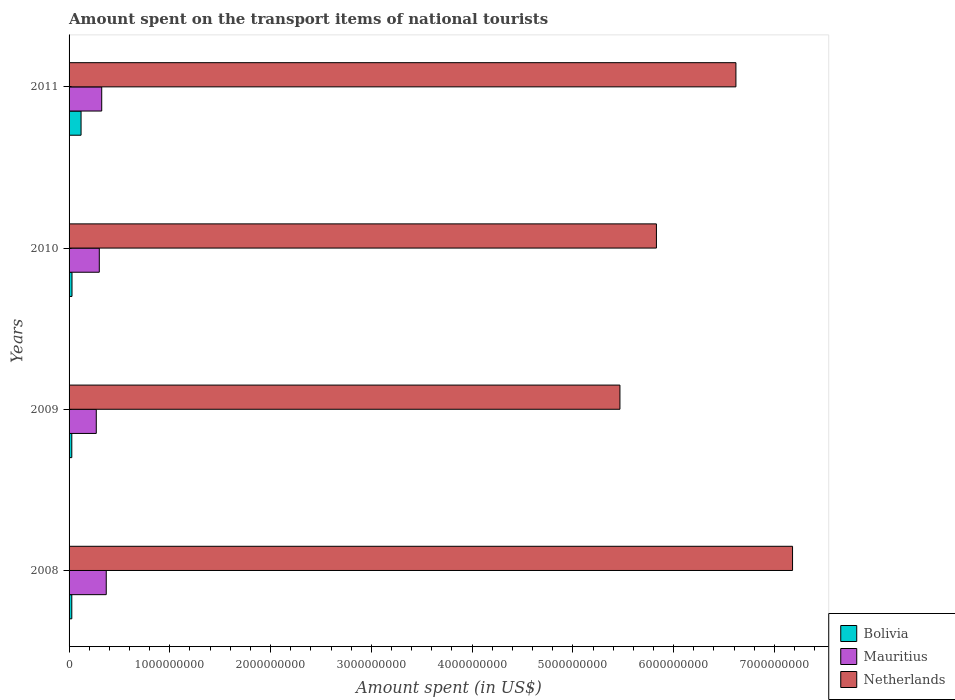How many different coloured bars are there?
Give a very brief answer. 3. Are the number of bars per tick equal to the number of legend labels?
Your answer should be very brief. Yes. How many bars are there on the 2nd tick from the top?
Keep it short and to the point. 3. In how many cases, is the number of bars for a given year not equal to the number of legend labels?
Offer a terse response. 0. What is the amount spent on the transport items of national tourists in Bolivia in 2011?
Keep it short and to the point. 1.19e+08. Across all years, what is the maximum amount spent on the transport items of national tourists in Bolivia?
Offer a terse response. 1.19e+08. Across all years, what is the minimum amount spent on the transport items of national tourists in Bolivia?
Your answer should be compact. 2.70e+07. In which year was the amount spent on the transport items of national tourists in Bolivia minimum?
Your answer should be very brief. 2008. What is the total amount spent on the transport items of national tourists in Bolivia in the graph?
Your answer should be compact. 2.02e+08. What is the difference between the amount spent on the transport items of national tourists in Bolivia in 2010 and that in 2011?
Your answer should be very brief. -9.00e+07. What is the difference between the amount spent on the transport items of national tourists in Netherlands in 2010 and the amount spent on the transport items of national tourists in Bolivia in 2011?
Offer a very short reply. 5.71e+09. What is the average amount spent on the transport items of national tourists in Mauritius per year?
Provide a succinct answer. 3.16e+08. In the year 2008, what is the difference between the amount spent on the transport items of national tourists in Netherlands and amount spent on the transport items of national tourists in Bolivia?
Make the answer very short. 7.15e+09. What is the ratio of the amount spent on the transport items of national tourists in Netherlands in 2009 to that in 2010?
Make the answer very short. 0.94. What is the difference between the highest and the second highest amount spent on the transport items of national tourists in Netherlands?
Offer a very short reply. 5.62e+08. What is the difference between the highest and the lowest amount spent on the transport items of national tourists in Netherlands?
Offer a terse response. 1.71e+09. In how many years, is the amount spent on the transport items of national tourists in Netherlands greater than the average amount spent on the transport items of national tourists in Netherlands taken over all years?
Provide a short and direct response. 2. Is the sum of the amount spent on the transport items of national tourists in Mauritius in 2008 and 2009 greater than the maximum amount spent on the transport items of national tourists in Netherlands across all years?
Offer a terse response. No. How many bars are there?
Provide a short and direct response. 12. Are all the bars in the graph horizontal?
Ensure brevity in your answer.  Yes. How many years are there in the graph?
Your response must be concise. 4. Are the values on the major ticks of X-axis written in scientific E-notation?
Your answer should be very brief. No. How many legend labels are there?
Your answer should be compact. 3. What is the title of the graph?
Offer a terse response. Amount spent on the transport items of national tourists. What is the label or title of the X-axis?
Provide a succinct answer. Amount spent (in US$). What is the Amount spent (in US$) of Bolivia in 2008?
Make the answer very short. 2.70e+07. What is the Amount spent (in US$) in Mauritius in 2008?
Your answer should be very brief. 3.69e+08. What is the Amount spent (in US$) in Netherlands in 2008?
Your answer should be compact. 7.18e+09. What is the Amount spent (in US$) in Bolivia in 2009?
Keep it short and to the point. 2.70e+07. What is the Amount spent (in US$) in Mauritius in 2009?
Your answer should be very brief. 2.70e+08. What is the Amount spent (in US$) of Netherlands in 2009?
Give a very brief answer. 5.47e+09. What is the Amount spent (in US$) of Bolivia in 2010?
Offer a terse response. 2.90e+07. What is the Amount spent (in US$) of Mauritius in 2010?
Your response must be concise. 3.00e+08. What is the Amount spent (in US$) in Netherlands in 2010?
Give a very brief answer. 5.83e+09. What is the Amount spent (in US$) of Bolivia in 2011?
Keep it short and to the point. 1.19e+08. What is the Amount spent (in US$) in Mauritius in 2011?
Your answer should be compact. 3.24e+08. What is the Amount spent (in US$) in Netherlands in 2011?
Provide a short and direct response. 6.62e+09. Across all years, what is the maximum Amount spent (in US$) in Bolivia?
Offer a terse response. 1.19e+08. Across all years, what is the maximum Amount spent (in US$) of Mauritius?
Provide a succinct answer. 3.69e+08. Across all years, what is the maximum Amount spent (in US$) in Netherlands?
Your answer should be compact. 7.18e+09. Across all years, what is the minimum Amount spent (in US$) in Bolivia?
Offer a very short reply. 2.70e+07. Across all years, what is the minimum Amount spent (in US$) of Mauritius?
Your response must be concise. 2.70e+08. Across all years, what is the minimum Amount spent (in US$) of Netherlands?
Your answer should be compact. 5.47e+09. What is the total Amount spent (in US$) in Bolivia in the graph?
Provide a succinct answer. 2.02e+08. What is the total Amount spent (in US$) in Mauritius in the graph?
Provide a short and direct response. 1.26e+09. What is the total Amount spent (in US$) in Netherlands in the graph?
Provide a succinct answer. 2.51e+1. What is the difference between the Amount spent (in US$) of Bolivia in 2008 and that in 2009?
Your answer should be very brief. 0. What is the difference between the Amount spent (in US$) in Mauritius in 2008 and that in 2009?
Your response must be concise. 9.90e+07. What is the difference between the Amount spent (in US$) of Netherlands in 2008 and that in 2009?
Keep it short and to the point. 1.71e+09. What is the difference between the Amount spent (in US$) in Mauritius in 2008 and that in 2010?
Offer a terse response. 6.90e+07. What is the difference between the Amount spent (in US$) of Netherlands in 2008 and that in 2010?
Offer a very short reply. 1.35e+09. What is the difference between the Amount spent (in US$) in Bolivia in 2008 and that in 2011?
Your answer should be very brief. -9.20e+07. What is the difference between the Amount spent (in US$) in Mauritius in 2008 and that in 2011?
Give a very brief answer. 4.50e+07. What is the difference between the Amount spent (in US$) of Netherlands in 2008 and that in 2011?
Provide a short and direct response. 5.62e+08. What is the difference between the Amount spent (in US$) in Mauritius in 2009 and that in 2010?
Make the answer very short. -3.00e+07. What is the difference between the Amount spent (in US$) in Netherlands in 2009 and that in 2010?
Provide a succinct answer. -3.62e+08. What is the difference between the Amount spent (in US$) in Bolivia in 2009 and that in 2011?
Your answer should be very brief. -9.20e+07. What is the difference between the Amount spent (in US$) in Mauritius in 2009 and that in 2011?
Ensure brevity in your answer.  -5.40e+07. What is the difference between the Amount spent (in US$) of Netherlands in 2009 and that in 2011?
Give a very brief answer. -1.15e+09. What is the difference between the Amount spent (in US$) in Bolivia in 2010 and that in 2011?
Make the answer very short. -9.00e+07. What is the difference between the Amount spent (in US$) of Mauritius in 2010 and that in 2011?
Provide a short and direct response. -2.40e+07. What is the difference between the Amount spent (in US$) of Netherlands in 2010 and that in 2011?
Offer a very short reply. -7.89e+08. What is the difference between the Amount spent (in US$) in Bolivia in 2008 and the Amount spent (in US$) in Mauritius in 2009?
Give a very brief answer. -2.43e+08. What is the difference between the Amount spent (in US$) of Bolivia in 2008 and the Amount spent (in US$) of Netherlands in 2009?
Offer a very short reply. -5.44e+09. What is the difference between the Amount spent (in US$) in Mauritius in 2008 and the Amount spent (in US$) in Netherlands in 2009?
Ensure brevity in your answer.  -5.10e+09. What is the difference between the Amount spent (in US$) of Bolivia in 2008 and the Amount spent (in US$) of Mauritius in 2010?
Provide a succinct answer. -2.73e+08. What is the difference between the Amount spent (in US$) of Bolivia in 2008 and the Amount spent (in US$) of Netherlands in 2010?
Make the answer very short. -5.80e+09. What is the difference between the Amount spent (in US$) in Mauritius in 2008 and the Amount spent (in US$) in Netherlands in 2010?
Ensure brevity in your answer.  -5.46e+09. What is the difference between the Amount spent (in US$) in Bolivia in 2008 and the Amount spent (in US$) in Mauritius in 2011?
Make the answer very short. -2.97e+08. What is the difference between the Amount spent (in US$) in Bolivia in 2008 and the Amount spent (in US$) in Netherlands in 2011?
Offer a very short reply. -6.59e+09. What is the difference between the Amount spent (in US$) in Mauritius in 2008 and the Amount spent (in US$) in Netherlands in 2011?
Your answer should be compact. -6.25e+09. What is the difference between the Amount spent (in US$) in Bolivia in 2009 and the Amount spent (in US$) in Mauritius in 2010?
Your answer should be compact. -2.73e+08. What is the difference between the Amount spent (in US$) in Bolivia in 2009 and the Amount spent (in US$) in Netherlands in 2010?
Provide a succinct answer. -5.80e+09. What is the difference between the Amount spent (in US$) of Mauritius in 2009 and the Amount spent (in US$) of Netherlands in 2010?
Give a very brief answer. -5.56e+09. What is the difference between the Amount spent (in US$) in Bolivia in 2009 and the Amount spent (in US$) in Mauritius in 2011?
Provide a succinct answer. -2.97e+08. What is the difference between the Amount spent (in US$) in Bolivia in 2009 and the Amount spent (in US$) in Netherlands in 2011?
Your answer should be compact. -6.59e+09. What is the difference between the Amount spent (in US$) in Mauritius in 2009 and the Amount spent (in US$) in Netherlands in 2011?
Give a very brief answer. -6.35e+09. What is the difference between the Amount spent (in US$) in Bolivia in 2010 and the Amount spent (in US$) in Mauritius in 2011?
Your answer should be very brief. -2.95e+08. What is the difference between the Amount spent (in US$) of Bolivia in 2010 and the Amount spent (in US$) of Netherlands in 2011?
Provide a short and direct response. -6.59e+09. What is the difference between the Amount spent (in US$) in Mauritius in 2010 and the Amount spent (in US$) in Netherlands in 2011?
Offer a very short reply. -6.32e+09. What is the average Amount spent (in US$) of Bolivia per year?
Make the answer very short. 5.05e+07. What is the average Amount spent (in US$) in Mauritius per year?
Make the answer very short. 3.16e+08. What is the average Amount spent (in US$) of Netherlands per year?
Your answer should be compact. 6.27e+09. In the year 2008, what is the difference between the Amount spent (in US$) of Bolivia and Amount spent (in US$) of Mauritius?
Provide a succinct answer. -3.42e+08. In the year 2008, what is the difference between the Amount spent (in US$) of Bolivia and Amount spent (in US$) of Netherlands?
Make the answer very short. -7.15e+09. In the year 2008, what is the difference between the Amount spent (in US$) of Mauritius and Amount spent (in US$) of Netherlands?
Offer a terse response. -6.81e+09. In the year 2009, what is the difference between the Amount spent (in US$) of Bolivia and Amount spent (in US$) of Mauritius?
Offer a very short reply. -2.43e+08. In the year 2009, what is the difference between the Amount spent (in US$) of Bolivia and Amount spent (in US$) of Netherlands?
Keep it short and to the point. -5.44e+09. In the year 2009, what is the difference between the Amount spent (in US$) in Mauritius and Amount spent (in US$) in Netherlands?
Your response must be concise. -5.20e+09. In the year 2010, what is the difference between the Amount spent (in US$) of Bolivia and Amount spent (in US$) of Mauritius?
Keep it short and to the point. -2.71e+08. In the year 2010, what is the difference between the Amount spent (in US$) of Bolivia and Amount spent (in US$) of Netherlands?
Your response must be concise. -5.80e+09. In the year 2010, what is the difference between the Amount spent (in US$) in Mauritius and Amount spent (in US$) in Netherlands?
Offer a terse response. -5.53e+09. In the year 2011, what is the difference between the Amount spent (in US$) in Bolivia and Amount spent (in US$) in Mauritius?
Your response must be concise. -2.05e+08. In the year 2011, what is the difference between the Amount spent (in US$) of Bolivia and Amount spent (in US$) of Netherlands?
Offer a terse response. -6.50e+09. In the year 2011, what is the difference between the Amount spent (in US$) in Mauritius and Amount spent (in US$) in Netherlands?
Keep it short and to the point. -6.29e+09. What is the ratio of the Amount spent (in US$) in Mauritius in 2008 to that in 2009?
Make the answer very short. 1.37. What is the ratio of the Amount spent (in US$) of Netherlands in 2008 to that in 2009?
Provide a short and direct response. 1.31. What is the ratio of the Amount spent (in US$) of Mauritius in 2008 to that in 2010?
Offer a very short reply. 1.23. What is the ratio of the Amount spent (in US$) of Netherlands in 2008 to that in 2010?
Keep it short and to the point. 1.23. What is the ratio of the Amount spent (in US$) of Bolivia in 2008 to that in 2011?
Your response must be concise. 0.23. What is the ratio of the Amount spent (in US$) of Mauritius in 2008 to that in 2011?
Your response must be concise. 1.14. What is the ratio of the Amount spent (in US$) in Netherlands in 2008 to that in 2011?
Offer a very short reply. 1.08. What is the ratio of the Amount spent (in US$) of Bolivia in 2009 to that in 2010?
Ensure brevity in your answer.  0.93. What is the ratio of the Amount spent (in US$) in Mauritius in 2009 to that in 2010?
Keep it short and to the point. 0.9. What is the ratio of the Amount spent (in US$) of Netherlands in 2009 to that in 2010?
Your response must be concise. 0.94. What is the ratio of the Amount spent (in US$) of Bolivia in 2009 to that in 2011?
Your response must be concise. 0.23. What is the ratio of the Amount spent (in US$) of Netherlands in 2009 to that in 2011?
Provide a succinct answer. 0.83. What is the ratio of the Amount spent (in US$) of Bolivia in 2010 to that in 2011?
Your answer should be very brief. 0.24. What is the ratio of the Amount spent (in US$) in Mauritius in 2010 to that in 2011?
Your answer should be compact. 0.93. What is the ratio of the Amount spent (in US$) of Netherlands in 2010 to that in 2011?
Give a very brief answer. 0.88. What is the difference between the highest and the second highest Amount spent (in US$) of Bolivia?
Make the answer very short. 9.00e+07. What is the difference between the highest and the second highest Amount spent (in US$) in Mauritius?
Give a very brief answer. 4.50e+07. What is the difference between the highest and the second highest Amount spent (in US$) in Netherlands?
Offer a very short reply. 5.62e+08. What is the difference between the highest and the lowest Amount spent (in US$) in Bolivia?
Your answer should be compact. 9.20e+07. What is the difference between the highest and the lowest Amount spent (in US$) in Mauritius?
Your response must be concise. 9.90e+07. What is the difference between the highest and the lowest Amount spent (in US$) of Netherlands?
Your answer should be very brief. 1.71e+09. 